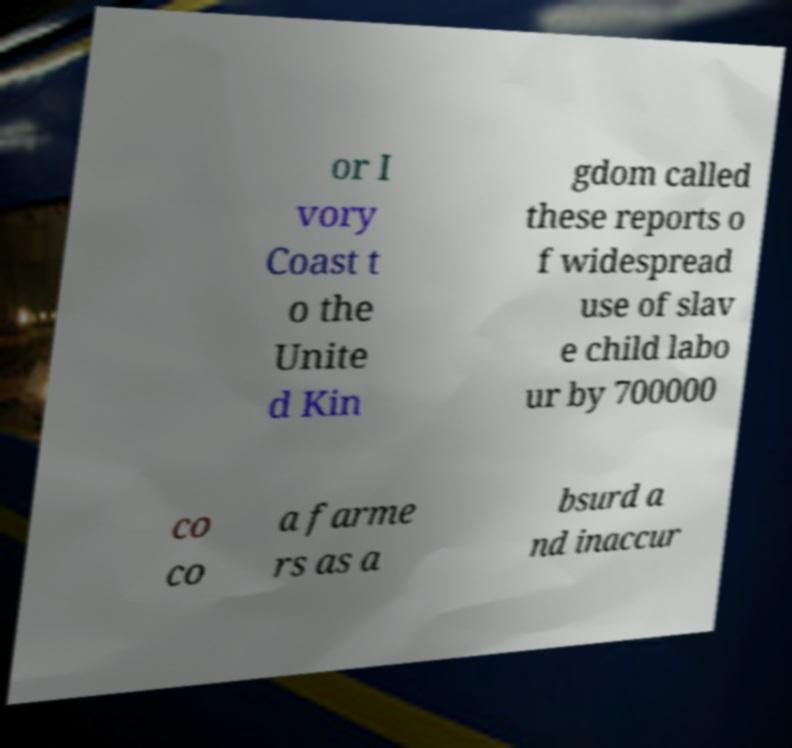Can you read and provide the text displayed in the image?This photo seems to have some interesting text. Can you extract and type it out for me? or I vory Coast t o the Unite d Kin gdom called these reports o f widespread use of slav e child labo ur by 700000 co co a farme rs as a bsurd a nd inaccur 